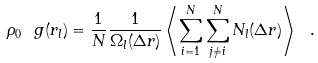<formula> <loc_0><loc_0><loc_500><loc_500>\rho _ { 0 } \ g ( r _ { l } ) = \frac { 1 } { N } \frac { 1 } { \Omega _ { l } ( \Delta r ) } \left \langle \sum _ { i = 1 } ^ { N } \sum _ { j \neq i } ^ { N } N _ { l } ( \Delta r ) \right \rangle \ .</formula> 